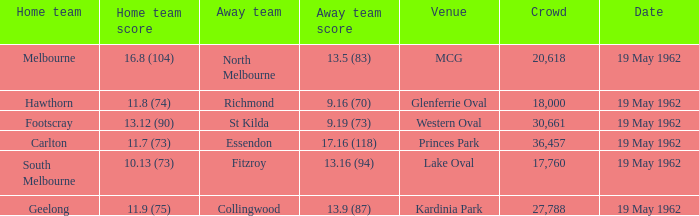On which day is the location the western oval? 19 May 1962. 